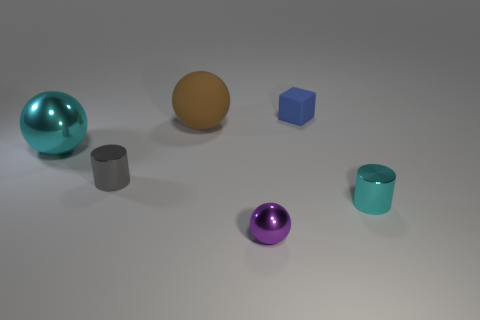Is there any other thing that is the same color as the rubber sphere?
Keep it short and to the point. No. What material is the purple thing?
Your response must be concise. Metal. There is a small shiny thing that is on the left side of the purple shiny ball; what is its shape?
Make the answer very short. Cylinder. The other cyan object that is made of the same material as the large cyan object is what size?
Provide a succinct answer. Small. The thing that is behind the tiny gray shiny object and to the left of the matte sphere has what shape?
Your answer should be compact. Sphere. Is the color of the metallic cylinder on the right side of the cube the same as the large metal sphere?
Your answer should be very brief. Yes. There is a cyan object to the right of the gray thing; does it have the same shape as the small thing to the left of the purple object?
Provide a succinct answer. Yes. There is a ball in front of the large shiny thing; what size is it?
Make the answer very short. Small. What is the size of the sphere that is in front of the cylinder right of the small purple object?
Your response must be concise. Small. Is the number of cubes greater than the number of balls?
Make the answer very short. No. 